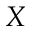Convert formula to latex. <formula><loc_0><loc_0><loc_500><loc_500>X</formula> 